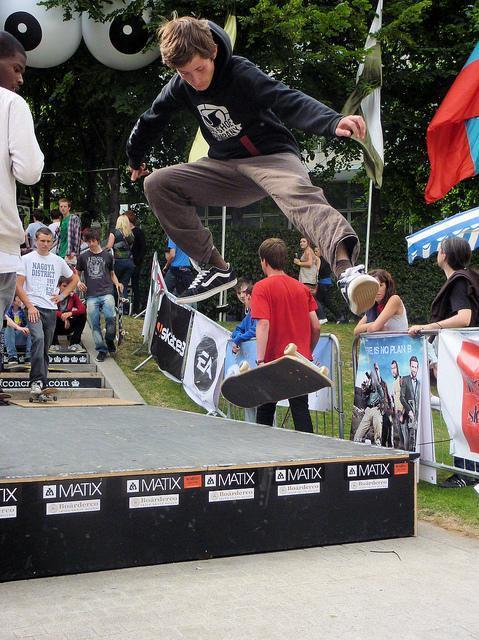How many skateboards are there?
Give a very brief answer. 1. How many people are in the picture?
Give a very brief answer. 6. How many blue cars are in the background?
Give a very brief answer. 0. 